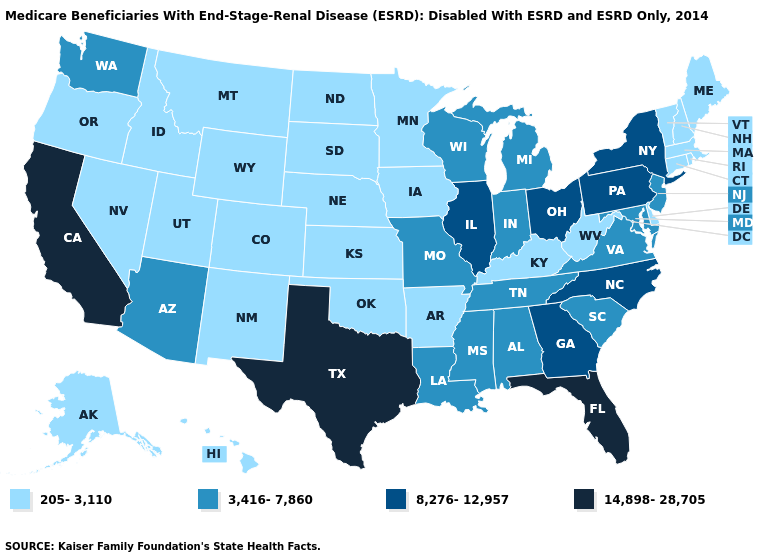Does Nevada have a lower value than Alabama?
Be succinct. Yes. Does Pennsylvania have the lowest value in the Northeast?
Concise answer only. No. Which states have the lowest value in the USA?
Give a very brief answer. Alaska, Arkansas, Colorado, Connecticut, Delaware, Hawaii, Idaho, Iowa, Kansas, Kentucky, Maine, Massachusetts, Minnesota, Montana, Nebraska, Nevada, New Hampshire, New Mexico, North Dakota, Oklahoma, Oregon, Rhode Island, South Dakota, Utah, Vermont, West Virginia, Wyoming. Name the states that have a value in the range 8,276-12,957?
Answer briefly. Georgia, Illinois, New York, North Carolina, Ohio, Pennsylvania. What is the value of Vermont?
Short answer required. 205-3,110. What is the value of Mississippi?
Give a very brief answer. 3,416-7,860. What is the highest value in the South ?
Short answer required. 14,898-28,705. What is the highest value in states that border Oklahoma?
Quick response, please. 14,898-28,705. Does Connecticut have the same value as Massachusetts?
Answer briefly. Yes. Is the legend a continuous bar?
Quick response, please. No. What is the value of New York?
Concise answer only. 8,276-12,957. Which states have the lowest value in the South?
Quick response, please. Arkansas, Delaware, Kentucky, Oklahoma, West Virginia. What is the highest value in states that border Montana?
Give a very brief answer. 205-3,110. What is the lowest value in the USA?
Concise answer only. 205-3,110. What is the lowest value in the USA?
Short answer required. 205-3,110. 